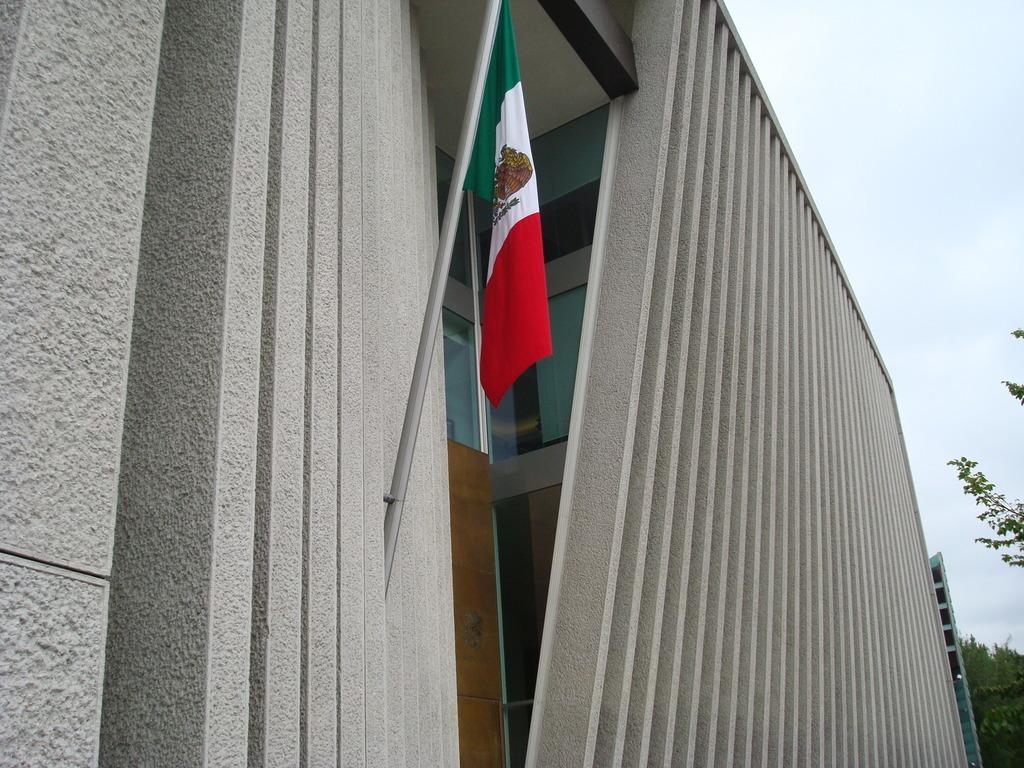Where was the picture taken? The picture was clicked outside. What can be seen on the left side of the image? There is a flag on the left side of the image. How is the flag positioned in the image? The flag is attached to the wall of a building. What is visible in the background of the image? There is a building, trees, and the sky visible in the background of the image. What type of throat lozenges are visible in the image? There are no throat lozenges present in the image. How many pins are holding the flag to the wall in the image? The image does not show any pins holding the flag to the wall; it is attached to the wall of the building. 